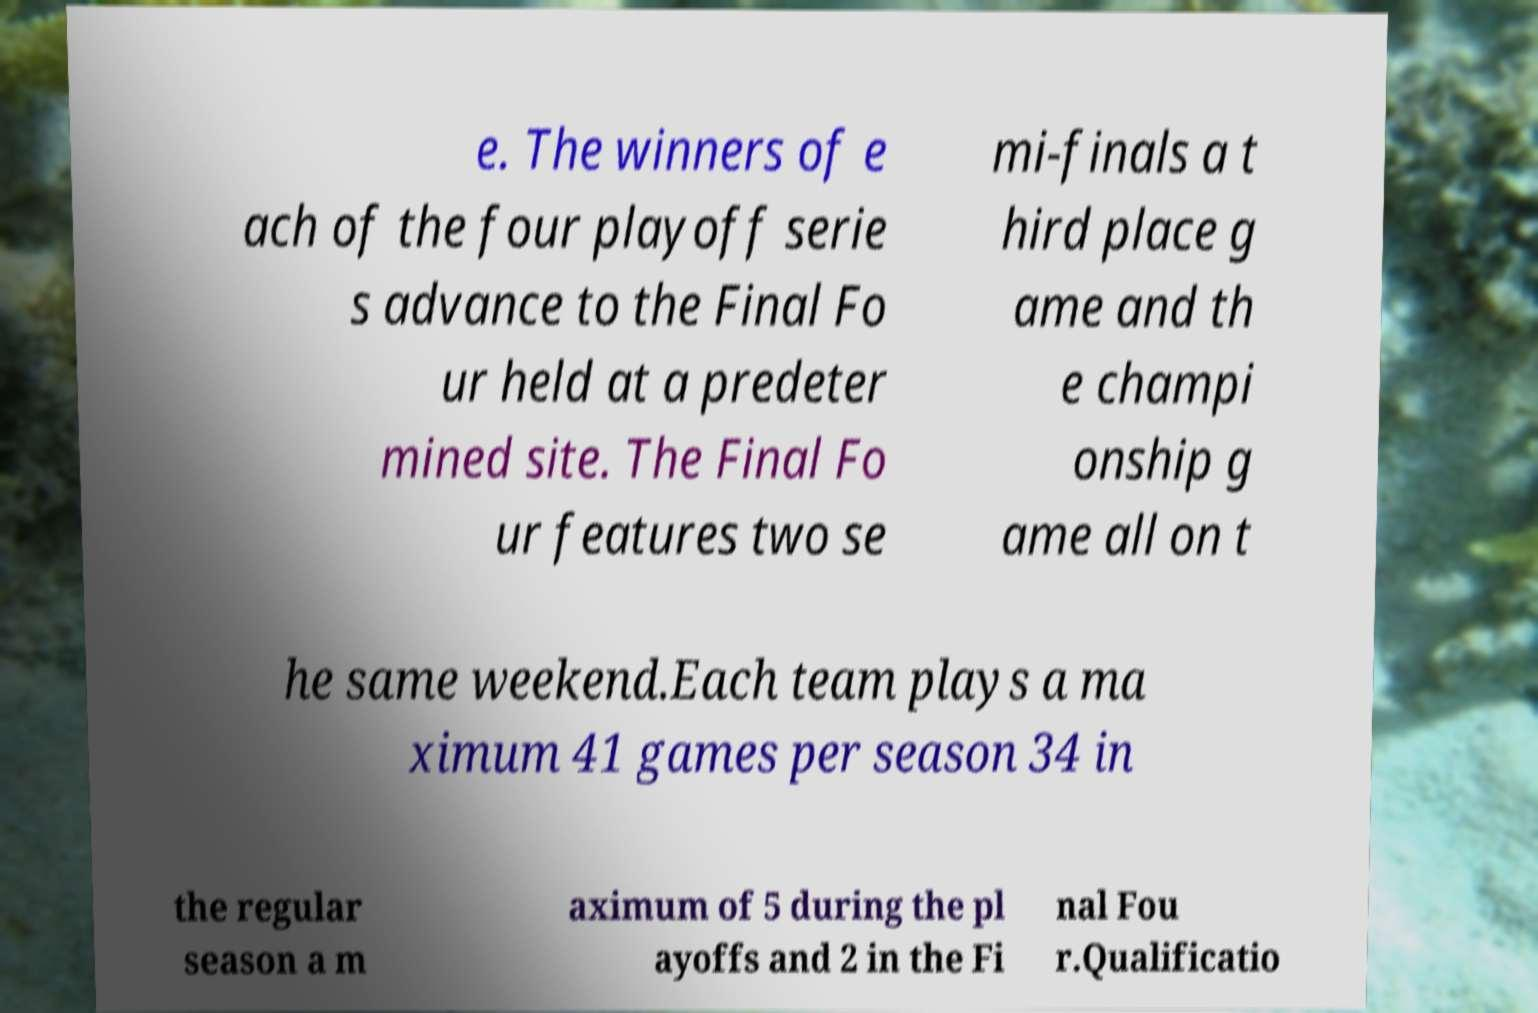Can you read and provide the text displayed in the image?This photo seems to have some interesting text. Can you extract and type it out for me? e. The winners of e ach of the four playoff serie s advance to the Final Fo ur held at a predeter mined site. The Final Fo ur features two se mi-finals a t hird place g ame and th e champi onship g ame all on t he same weekend.Each team plays a ma ximum 41 games per season 34 in the regular season a m aximum of 5 during the pl ayoffs and 2 in the Fi nal Fou r.Qualificatio 